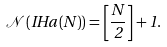Convert formula to latex. <formula><loc_0><loc_0><loc_500><loc_500>\mathcal { N } \left ( I H a \left ( N \right ) \right ) = \left [ \frac { N } { 2 } \right ] + 1 .</formula> 